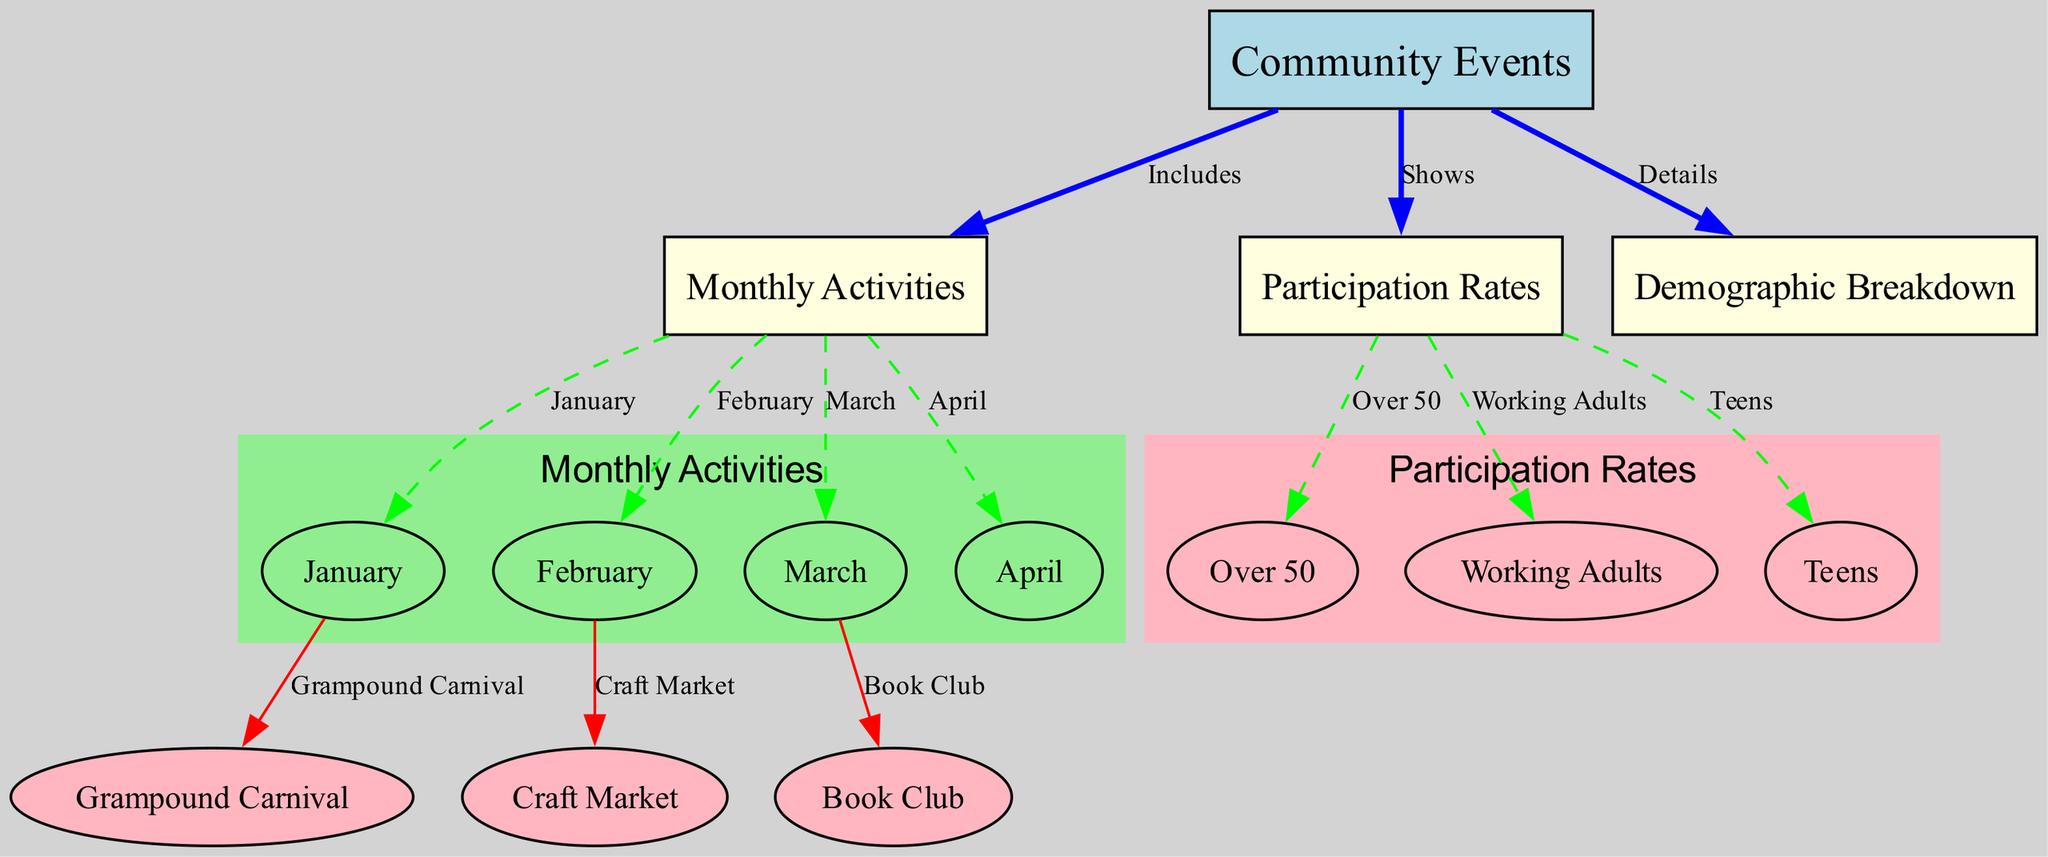What are the monthly activities included in the community events? The monthly activities are represented as nodes that branch out from the "Community Events" node. These activities are January, February, March, and April, indicating they are scheduled activities for those months.
Answer: January, February, March, April How many demographic groups are indicated in the diagram? The demographic groups can be counted by looking at the connections stemming from the "Participation Rates" node. There are three groups: Over 50, Working Adults, and Teens, each depicted as separate nodes.
Answer: 3 What type of activity occurs in January? The diagram shows one specific activity linked to the January node, which is represented by the Grampound Carnival. This indicates that this event takes place in January.
Answer: Grampound Carnival Which node represents the participation rate for the age group over 50? The "Over 50" node is directly connected to the "Participation Rates" node, representing the participation rate for individuals aged over 50.
Answer: Over 50 Which monthly activity is scheduled for February? According to the edges from the "February" node, the activity connected to it is the Craft Market, indicating that this event is held in February.
Answer: Craft Market What relationship do "community events" and "demographic breakdown" share? The "community events" node has a direct edge pointing to the "demographic breakdown," showing that the events provide detailed information regarding participation across demographics.
Answer: Details What is the total number of nodes representing monthly activities? By counting the nodes branching from the "monthly activities," we find that there are four nodes — one for each month of January, February, March, and April.
Answer: 4 What type of vehicle is used in the diagram to display edges between nodes? The edges are represented as directed connections (arrows) between the nodes, showcasing how they relate to each other. Each edge has labels that describe the nature of the connection, such as "Includes" or "Shows."
Answer: Directed edges Which event takes place in March according to the diagram? The node for March connects to the Book Club, indicating that this is the event scheduled for that month.
Answer: Book Club 